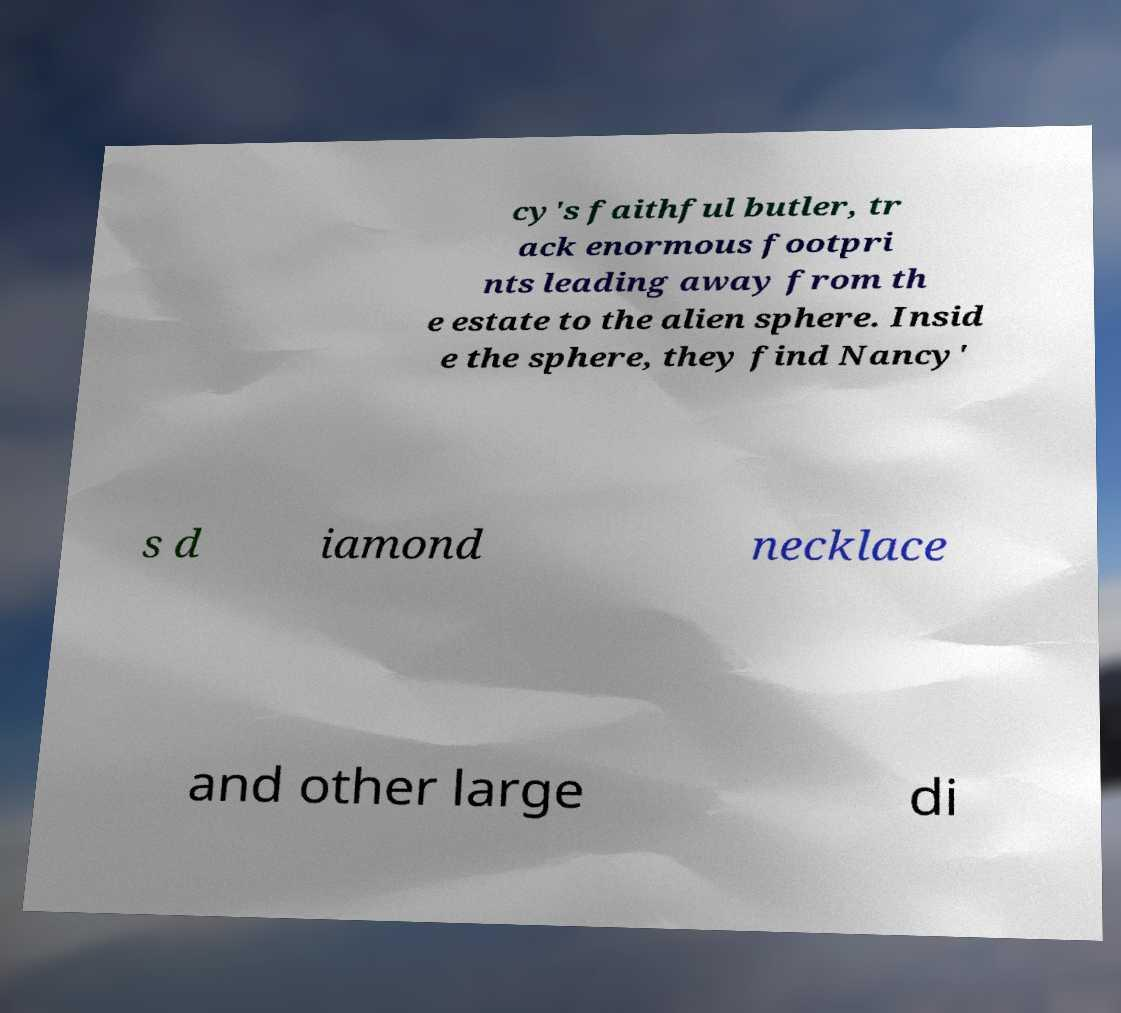Could you extract and type out the text from this image? cy's faithful butler, tr ack enormous footpri nts leading away from th e estate to the alien sphere. Insid e the sphere, they find Nancy' s d iamond necklace and other large di 